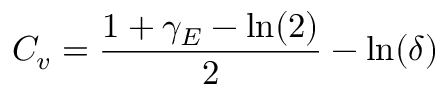Convert formula to latex. <formula><loc_0><loc_0><loc_500><loc_500>C _ { v } = \frac { 1 + \gamma _ { E } - \ln ( 2 ) } { 2 } - \ln ( \delta )</formula> 